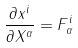<formula> <loc_0><loc_0><loc_500><loc_500>\frac { \partial x ^ { i } } { \partial X ^ { \alpha } } = F _ { \alpha } ^ { i }</formula> 